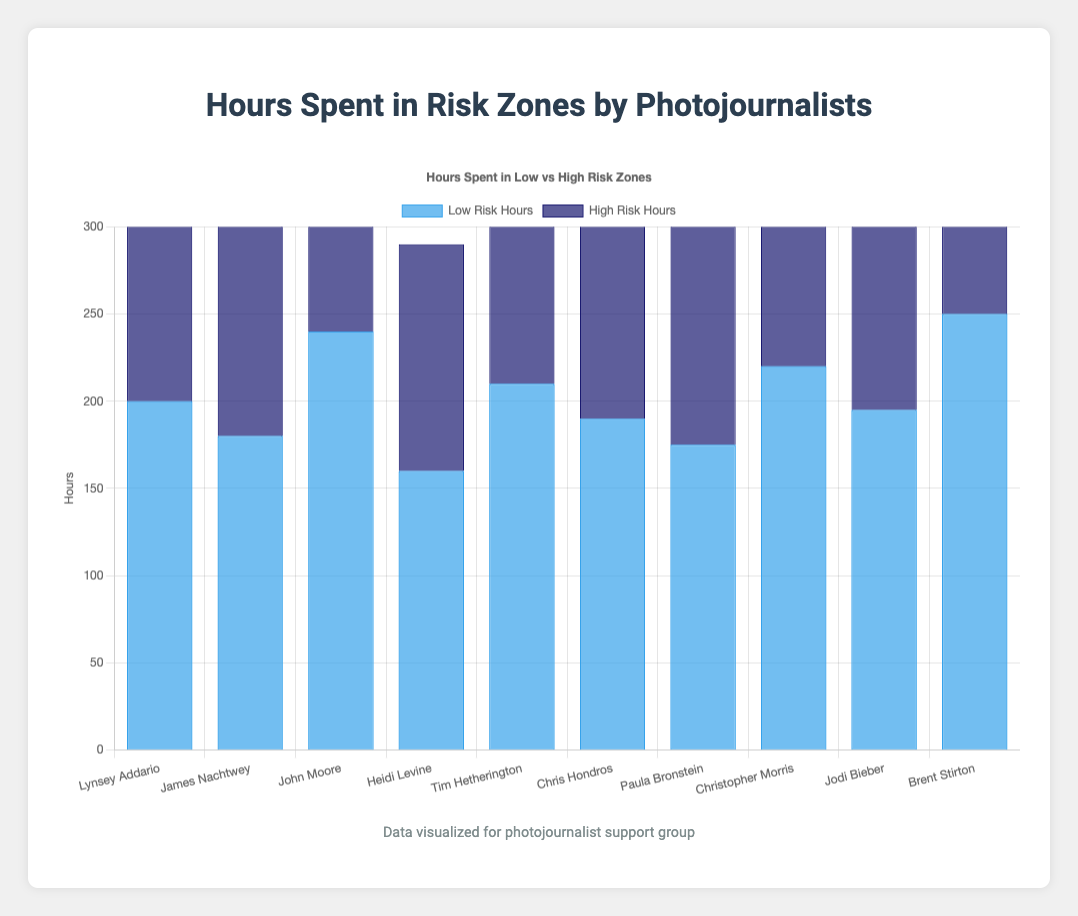Which photojournalist spent the most hours in low-risk zones? To identify this, compare the low-risk hours for each photojournalist. Brent Stirton has the highest low-risk hours at 250.
Answer: Brent Stirton Which photojournalist spent more time in high-risk zones than in low-risk zones? Compare the low-risk and high-risk hours for each photojournalist. Both James Nachtwey (220 vs 180) and Tim Hetherington (230 vs 210) spent more time in high-risk zones.
Answer: James Nachtwey and Tim Hetherington How many total hours did John Moore spend in low and high-risk zones? Sum the low-risk and high-risk hours for John Moore. 240 (low-risk) + 190 (high-risk) = 430 hours.
Answer: 430 hours What is the difference in high-risk hours between Lynsey Addario and Chris Hondros? Subtract Lynsey Addario’s high-risk hours from Chris Hondros’s high-risk hours. 210 (Chris) - 150 (Lynsey) = 60 hours.
Answer: 60 hours Which photojournalist has the smallest gap between low-risk and high-risk hours? Calculate the absolute difference between low-risk and high-risk hours for each. Heidi Levine has the smallest gap:
Answer: Heidi Levine Which two photojournalists have the highest total combined hours spent in both risk zones? Calculate the total hours for each photojournalist and identify the top two. Brent Stirton (250 + 200 = 450) and Tim Hetherington (210 + 230 = 440) have the highest combined totals.
Answer: Brent Stirton and Tim Hetherington Which photojournalist has the longest bar for high-risk hours? Visually identify the highest bar in the high-risk category. Tim Hetherington's high-risk hours bar is the longest at 230 hours.
Answer: Tim Hetherington On average, how many hours do these photojournalists spend in high-risk zones? Sum the high-risk hours for all and divide by the total number of photojournalists. (150 + 220 + 190 + 130 + 230 + 210 + 145 + 180 + 165 + 200) / 10 = 182 hours.
Answer: 182 hours What is the combined total of low-risk hours for Lynsey Addario, James Nachtwey, and Heidi Levine? Sum the low-risk hours for these three photojournalists. 200 (Lynsey) + 180 (James) + 160 (Heidi) = 540 hours.
Answer: 540 hours 